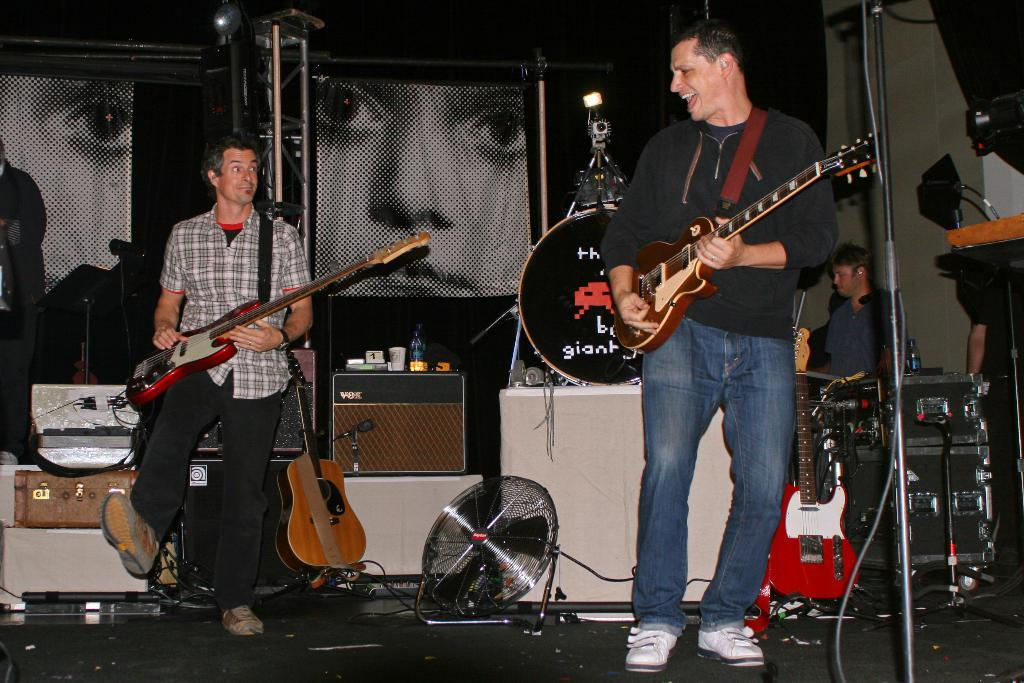How many people are in the image? There are two persons in the image. What are the persons doing in the image? The persons are playing the guitar. Where are the persons standing in the image? The persons are standing on the floor. What is used to hold the guitar when not in use? There is a guitar stand in the image. What other objects can be seen in the image? There are some objects in the image, but their specific details are not mentioned in the facts. What type of thread is being used to tie the umbrella in the image? There is no umbrella present in the image, so there is no thread being used to tie it. 